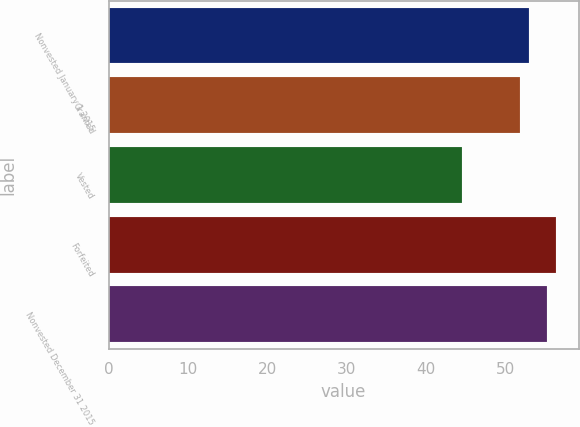Convert chart. <chart><loc_0><loc_0><loc_500><loc_500><bar_chart><fcel>Nonvested January 1 2015<fcel>Granted<fcel>Vested<fcel>Forfeited<fcel>Nonvested December 31 2015<nl><fcel>52.95<fcel>51.84<fcel>44.58<fcel>56.44<fcel>55.33<nl></chart> 